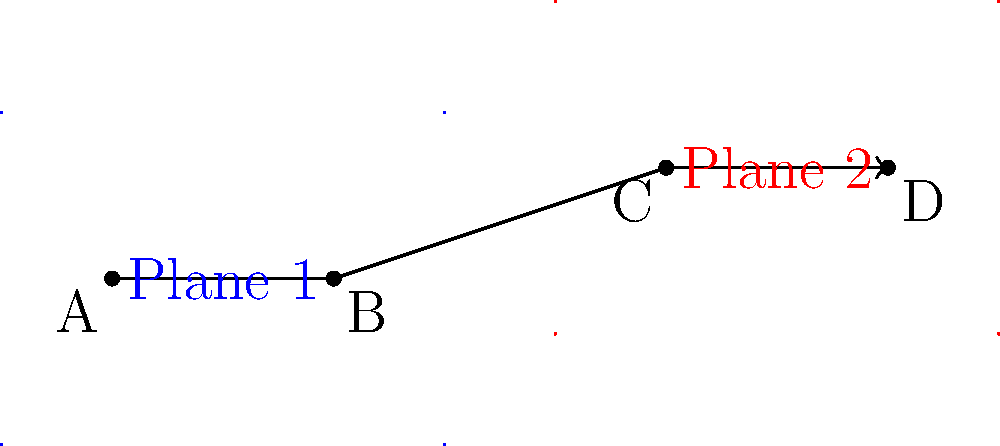In planning a complex action sequence for your upcoming film with Adria Arjona, you've mapped out the movement across two 2D planes. The sequence starts at point A, moves to point B on Plane 1, then transitions to point C on Plane 2, and ends at point D. If each unit on the graph represents 5 meters, what is the total distance traveled in the sequence, rounded to the nearest meter? To calculate the total distance traveled, we need to break down the sequence into segments and calculate each one:

1. Segment AB (on Plane 1):
   - Coordinates: A(1,1.5) to B(3,1.5)
   - Distance = $\sqrt{(3-1)^2 + (1.5-1.5)^2} = 2$ units

2. Segment BC (transition between planes):
   - Coordinates: B(3,1.5) to C(6,2.5)
   - Distance = $\sqrt{(6-3)^2 + (2.5-1.5)^2} = \sqrt{9 + 1} = \sqrt{10}$ units

3. Segment CD (on Plane 2):
   - Coordinates: C(6,2.5) to D(8,2.5)
   - Distance = $\sqrt{(8-6)^2 + (2.5-2.5)^2} = 2$ units

Total distance in units = $2 + \sqrt{10} + 2 = 4 + \sqrt{10}$ units

Convert to meters:
$(4 + \sqrt{10}) \times 5 = 20 + 5\sqrt{10}$ meters

$5\sqrt{10} \approx 15.81$ meters

Total distance = $20 + 15.81 = 35.81$ meters

Rounded to the nearest meter: 36 meters
Answer: 36 meters 